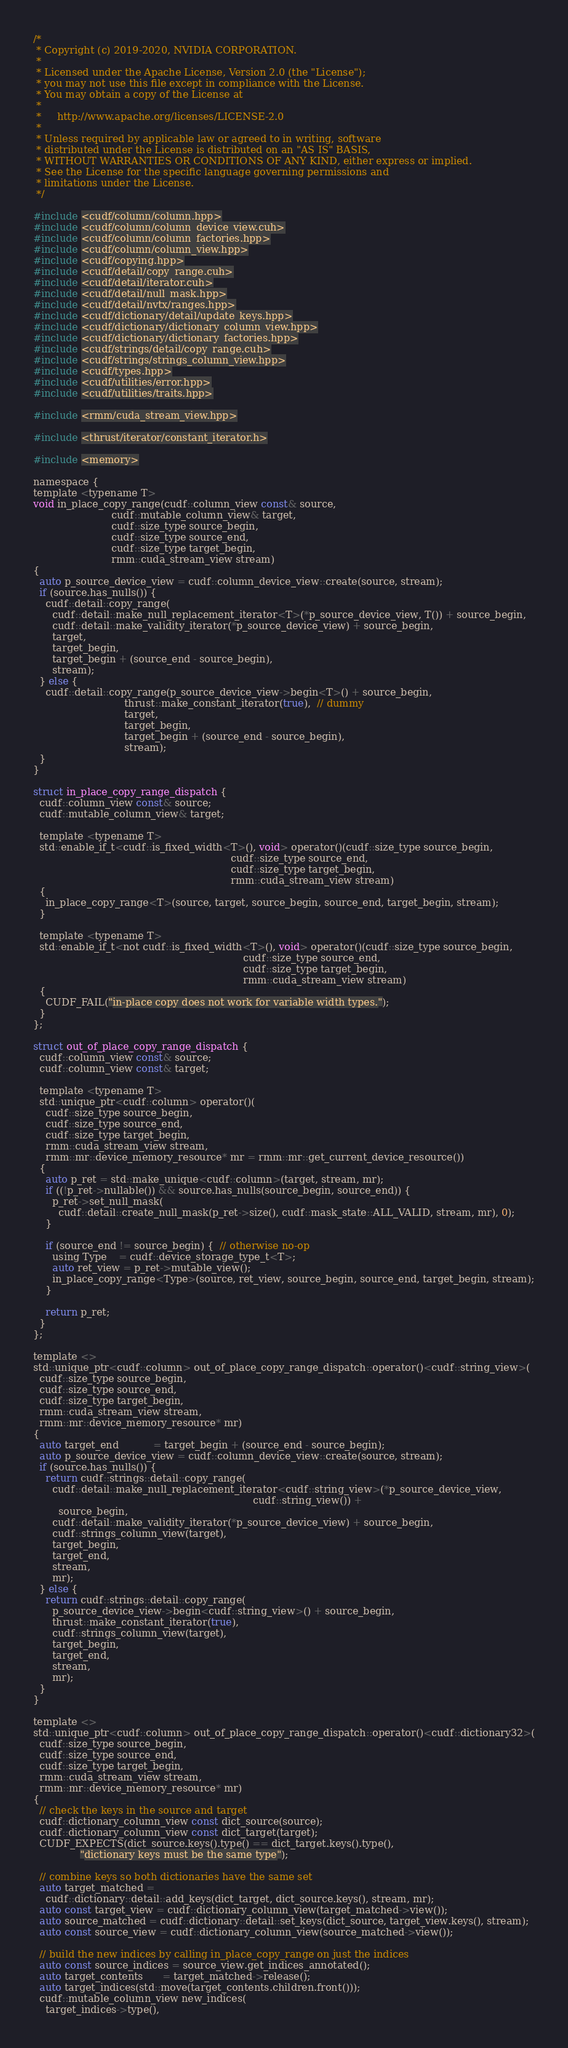<code> <loc_0><loc_0><loc_500><loc_500><_Cuda_>/*
 * Copyright (c) 2019-2020, NVIDIA CORPORATION.
 *
 * Licensed under the Apache License, Version 2.0 (the "License");
 * you may not use this file except in compliance with the License.
 * You may obtain a copy of the License at
 *
 *     http://www.apache.org/licenses/LICENSE-2.0
 *
 * Unless required by applicable law or agreed to in writing, software
 * distributed under the License is distributed on an "AS IS" BASIS,
 * WITHOUT WARRANTIES OR CONDITIONS OF ANY KIND, either express or implied.
 * See the License for the specific language governing permissions and
 * limitations under the License.
 */

#include <cudf/column/column.hpp>
#include <cudf/column/column_device_view.cuh>
#include <cudf/column/column_factories.hpp>
#include <cudf/column/column_view.hpp>
#include <cudf/copying.hpp>
#include <cudf/detail/copy_range.cuh>
#include <cudf/detail/iterator.cuh>
#include <cudf/detail/null_mask.hpp>
#include <cudf/detail/nvtx/ranges.hpp>
#include <cudf/dictionary/detail/update_keys.hpp>
#include <cudf/dictionary/dictionary_column_view.hpp>
#include <cudf/dictionary/dictionary_factories.hpp>
#include <cudf/strings/detail/copy_range.cuh>
#include <cudf/strings/strings_column_view.hpp>
#include <cudf/types.hpp>
#include <cudf/utilities/error.hpp>
#include <cudf/utilities/traits.hpp>

#include <rmm/cuda_stream_view.hpp>

#include <thrust/iterator/constant_iterator.h>

#include <memory>

namespace {
template <typename T>
void in_place_copy_range(cudf::column_view const& source,
                         cudf::mutable_column_view& target,
                         cudf::size_type source_begin,
                         cudf::size_type source_end,
                         cudf::size_type target_begin,
                         rmm::cuda_stream_view stream)
{
  auto p_source_device_view = cudf::column_device_view::create(source, stream);
  if (source.has_nulls()) {
    cudf::detail::copy_range(
      cudf::detail::make_null_replacement_iterator<T>(*p_source_device_view, T()) + source_begin,
      cudf::detail::make_validity_iterator(*p_source_device_view) + source_begin,
      target,
      target_begin,
      target_begin + (source_end - source_begin),
      stream);
  } else {
    cudf::detail::copy_range(p_source_device_view->begin<T>() + source_begin,
                             thrust::make_constant_iterator(true),  // dummy
                             target,
                             target_begin,
                             target_begin + (source_end - source_begin),
                             stream);
  }
}

struct in_place_copy_range_dispatch {
  cudf::column_view const& source;
  cudf::mutable_column_view& target;

  template <typename T>
  std::enable_if_t<cudf::is_fixed_width<T>(), void> operator()(cudf::size_type source_begin,
                                                               cudf::size_type source_end,
                                                               cudf::size_type target_begin,
                                                               rmm::cuda_stream_view stream)
  {
    in_place_copy_range<T>(source, target, source_begin, source_end, target_begin, stream);
  }

  template <typename T>
  std::enable_if_t<not cudf::is_fixed_width<T>(), void> operator()(cudf::size_type source_begin,
                                                                   cudf::size_type source_end,
                                                                   cudf::size_type target_begin,
                                                                   rmm::cuda_stream_view stream)
  {
    CUDF_FAIL("in-place copy does not work for variable width types.");
  }
};

struct out_of_place_copy_range_dispatch {
  cudf::column_view const& source;
  cudf::column_view const& target;

  template <typename T>
  std::unique_ptr<cudf::column> operator()(
    cudf::size_type source_begin,
    cudf::size_type source_end,
    cudf::size_type target_begin,
    rmm::cuda_stream_view stream,
    rmm::mr::device_memory_resource* mr = rmm::mr::get_current_device_resource())
  {
    auto p_ret = std::make_unique<cudf::column>(target, stream, mr);
    if ((!p_ret->nullable()) && source.has_nulls(source_begin, source_end)) {
      p_ret->set_null_mask(
        cudf::detail::create_null_mask(p_ret->size(), cudf::mask_state::ALL_VALID, stream, mr), 0);
    }

    if (source_end != source_begin) {  // otherwise no-op
      using Type    = cudf::device_storage_type_t<T>;
      auto ret_view = p_ret->mutable_view();
      in_place_copy_range<Type>(source, ret_view, source_begin, source_end, target_begin, stream);
    }

    return p_ret;
  }
};

template <>
std::unique_ptr<cudf::column> out_of_place_copy_range_dispatch::operator()<cudf::string_view>(
  cudf::size_type source_begin,
  cudf::size_type source_end,
  cudf::size_type target_begin,
  rmm::cuda_stream_view stream,
  rmm::mr::device_memory_resource* mr)
{
  auto target_end           = target_begin + (source_end - source_begin);
  auto p_source_device_view = cudf::column_device_view::create(source, stream);
  if (source.has_nulls()) {
    return cudf::strings::detail::copy_range(
      cudf::detail::make_null_replacement_iterator<cudf::string_view>(*p_source_device_view,
                                                                      cudf::string_view()) +
        source_begin,
      cudf::detail::make_validity_iterator(*p_source_device_view) + source_begin,
      cudf::strings_column_view(target),
      target_begin,
      target_end,
      stream,
      mr);
  } else {
    return cudf::strings::detail::copy_range(
      p_source_device_view->begin<cudf::string_view>() + source_begin,
      thrust::make_constant_iterator(true),
      cudf::strings_column_view(target),
      target_begin,
      target_end,
      stream,
      mr);
  }
}

template <>
std::unique_ptr<cudf::column> out_of_place_copy_range_dispatch::operator()<cudf::dictionary32>(
  cudf::size_type source_begin,
  cudf::size_type source_end,
  cudf::size_type target_begin,
  rmm::cuda_stream_view stream,
  rmm::mr::device_memory_resource* mr)
{
  // check the keys in the source and target
  cudf::dictionary_column_view const dict_source(source);
  cudf::dictionary_column_view const dict_target(target);
  CUDF_EXPECTS(dict_source.keys().type() == dict_target.keys().type(),
               "dictionary keys must be the same type");

  // combine keys so both dictionaries have the same set
  auto target_matched =
    cudf::dictionary::detail::add_keys(dict_target, dict_source.keys(), stream, mr);
  auto const target_view = cudf::dictionary_column_view(target_matched->view());
  auto source_matched = cudf::dictionary::detail::set_keys(dict_source, target_view.keys(), stream);
  auto const source_view = cudf::dictionary_column_view(source_matched->view());

  // build the new indices by calling in_place_copy_range on just the indices
  auto const source_indices = source_view.get_indices_annotated();
  auto target_contents      = target_matched->release();
  auto target_indices(std::move(target_contents.children.front()));
  cudf::mutable_column_view new_indices(
    target_indices->type(),</code> 